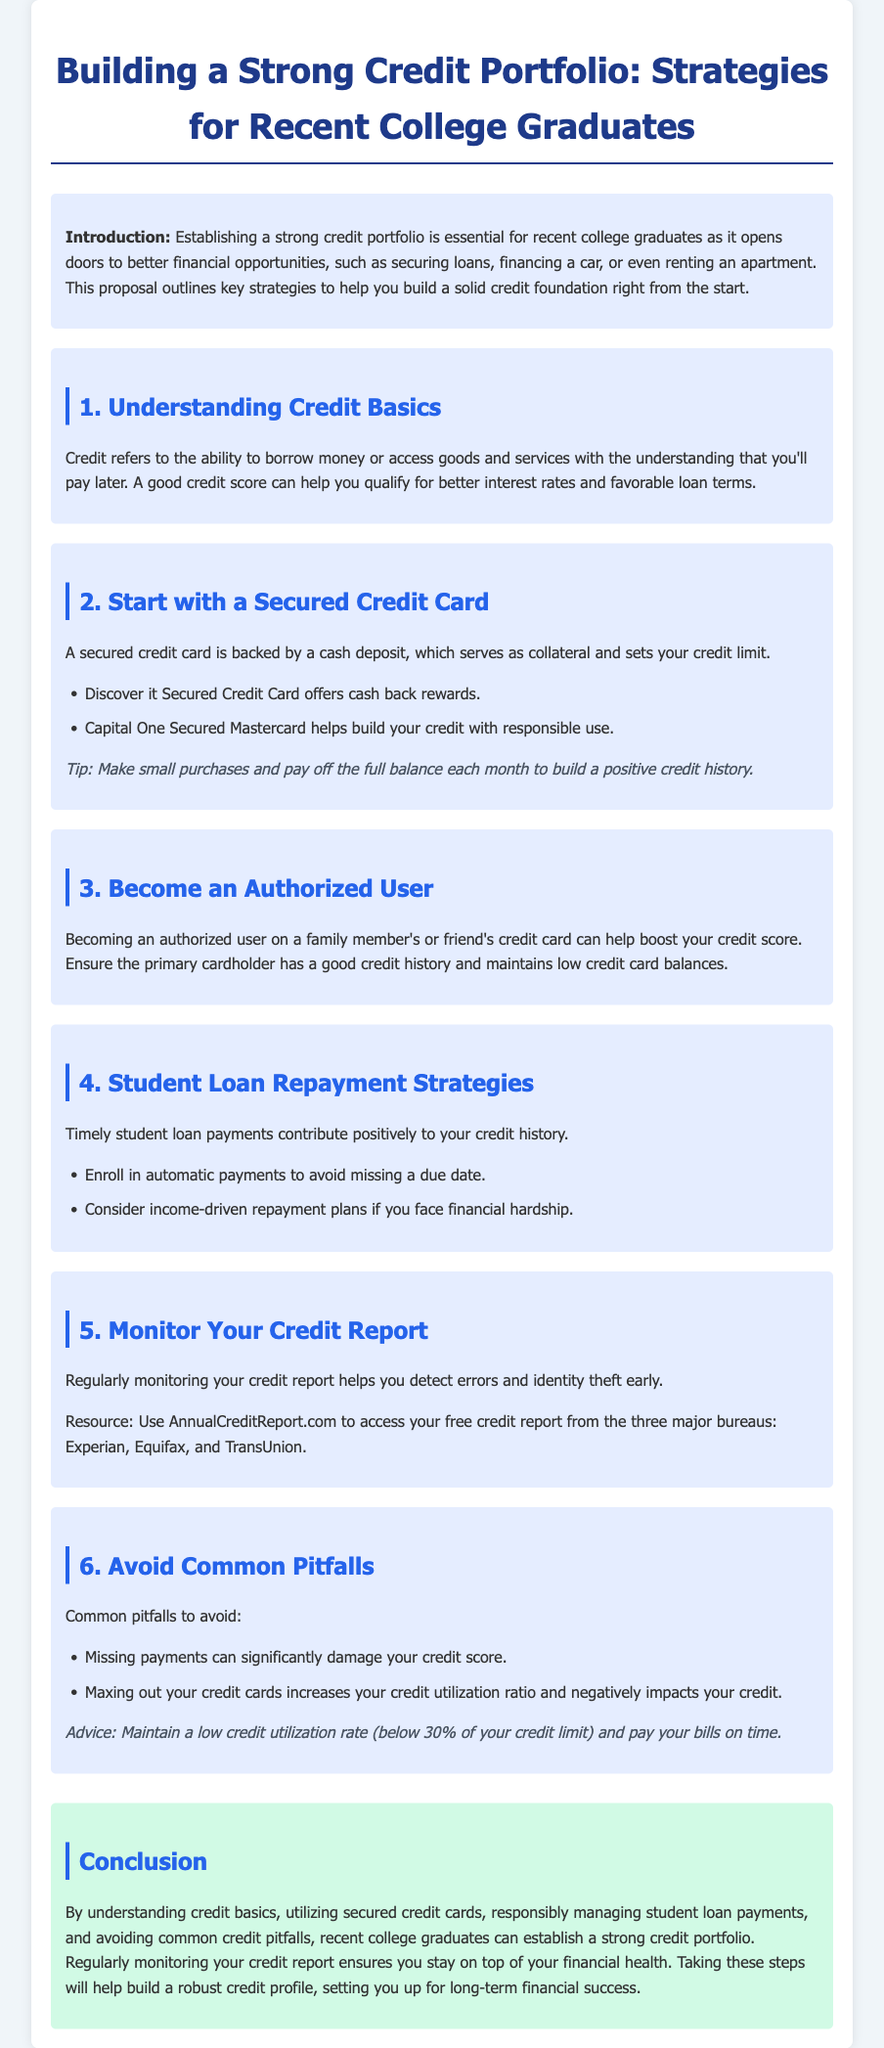what is the title of the proposal? The title of the proposal is stated at the beginning of the document.
Answer: Building a Strong Credit Portfolio: Strategies for Recent College Graduates what is one benefit of establishing a strong credit portfolio? The document highlights that a strong credit portfolio opens doors to better financial opportunities.
Answer: Better financial opportunities which secured credit card offers cash back rewards? The proposal lists specific secured credit cards and their features.
Answer: Discover it Secured Credit Card what should you do to avoid missing a due date for student loan payments? The proposal suggests strategies for managing student loan repayment.
Answer: Enroll in automatic payments what should you maintain your credit utilization rate below? The document advises on credit utilization to avoid pitfalls.
Answer: 30% why is it recommended to monitor your credit report regularly? The proposal mentions the importance of monitoring for specific reasons.
Answer: Detect errors and identity theft what is a resource mentioned for accessing your credit report? The document provides a specific resource for checking credit reports.
Answer: AnnualCreditReport.com what common pitfall can significantly damage your credit score? The proposal points out specific actions that can harm credit scores.
Answer: Missing payments 